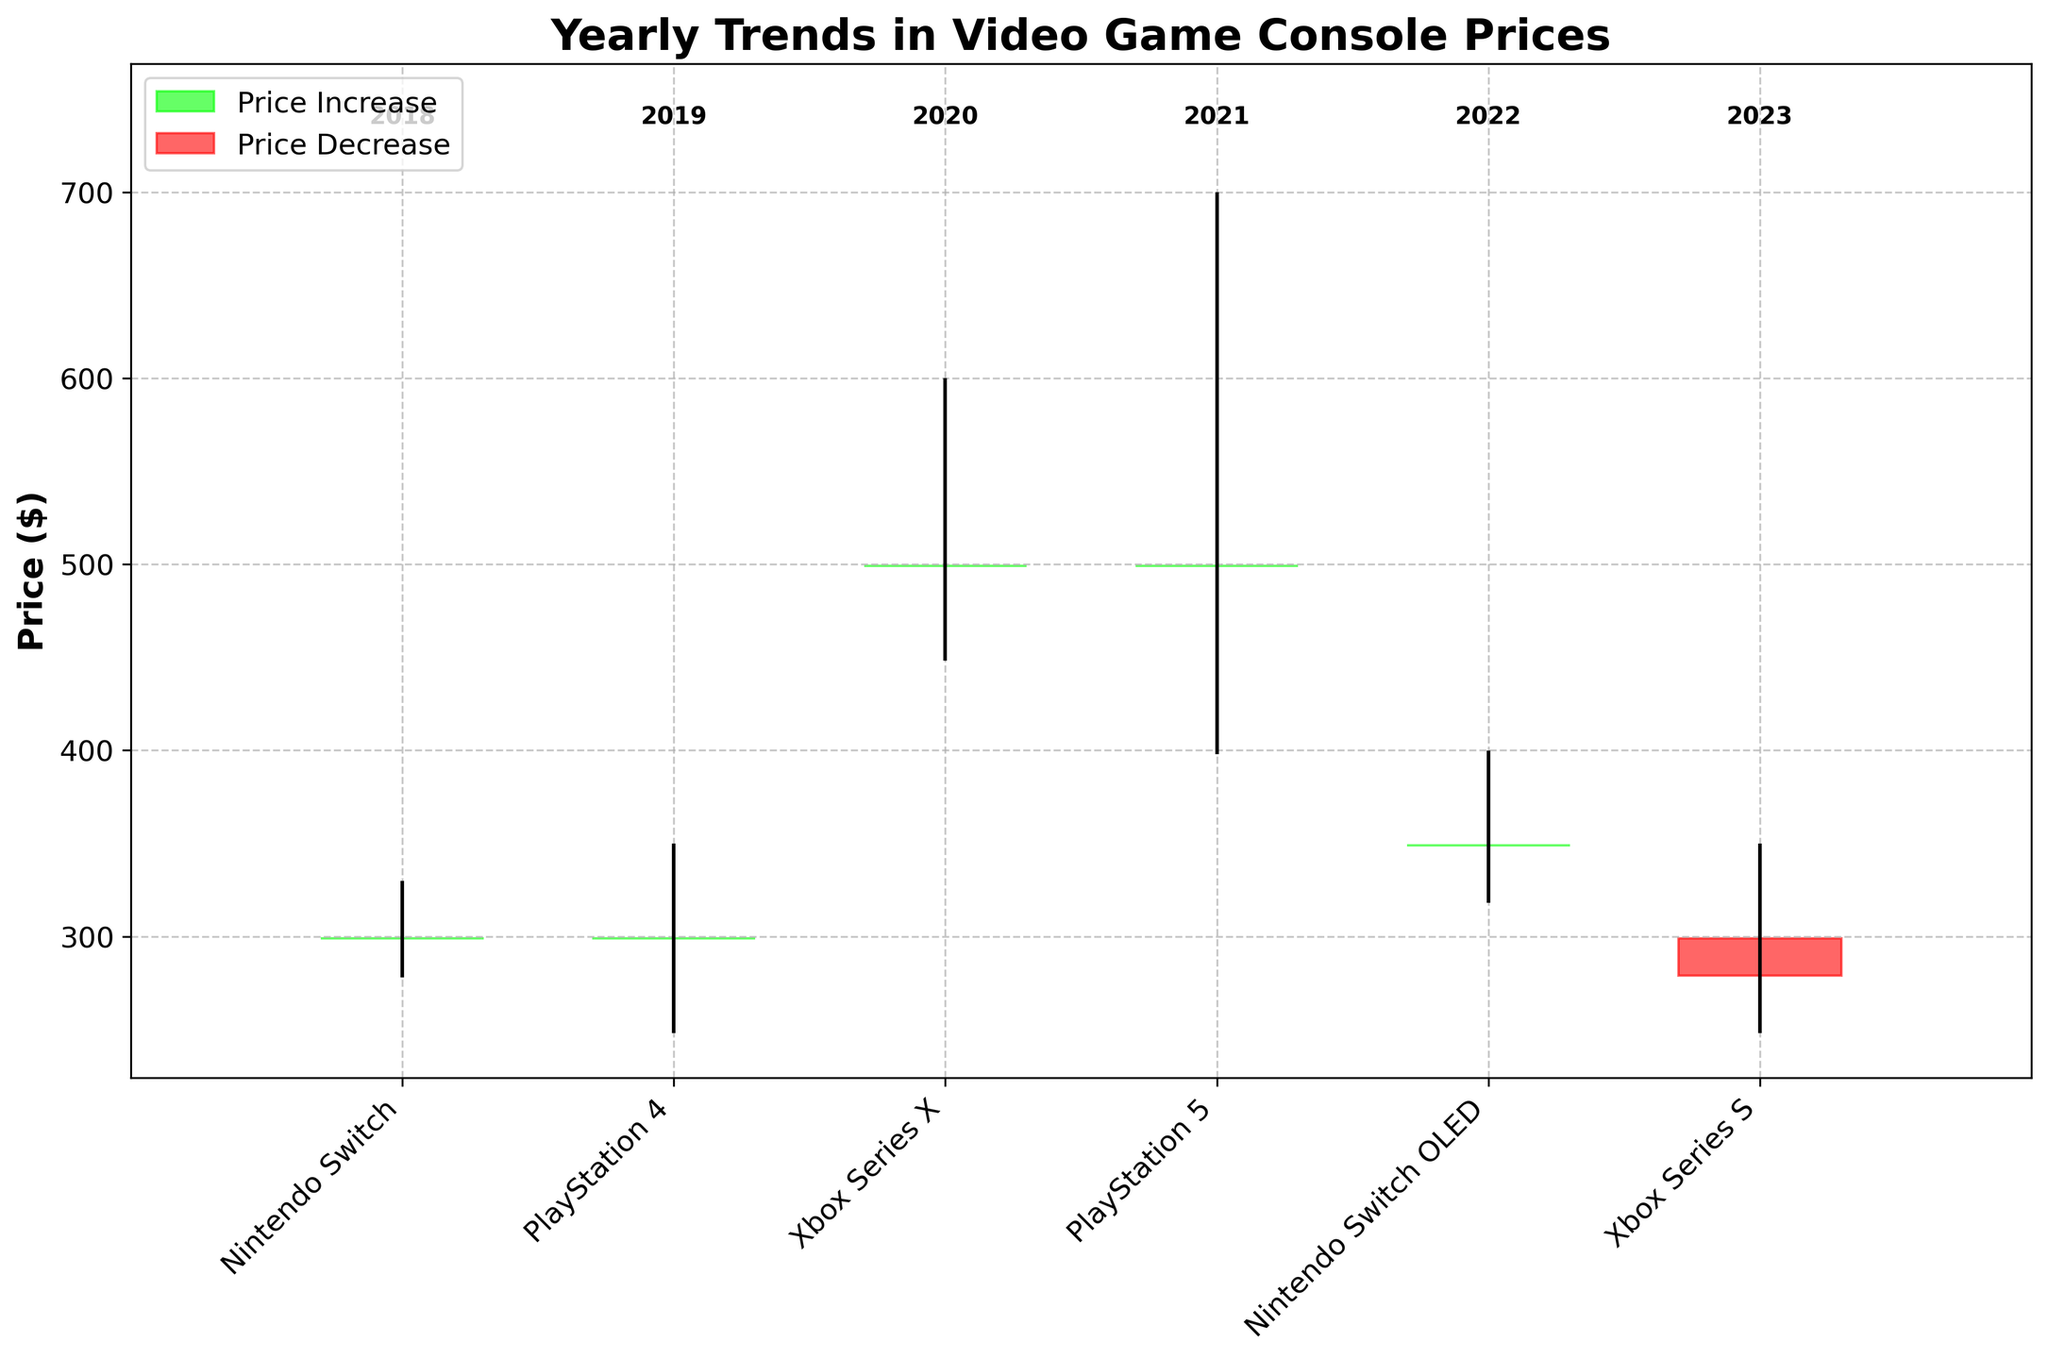What is the title of the plot? The title of the plot is usually located at the top and gives a brief description of the visualized data. Here, it is written as "Yearly Trends in Video Game Console Prices" in bold.
Answer: Yearly Trends in Video Game Console Prices Which consoles had their closing price equal to the opening price? Check the bars where the top and bottom of the rectangles are at the same level. This indicates that the closing price is equal to the opening price. For this figure, both the Nintendo Switch in 2018 and the PlayStation 4 in 2019 have such characteristics.
Answer: Nintendo Switch 2018 and PlayStation 4 2019 Was there any console whose closing price was lower than its opening price? Look for rectangles colored in red, indicating a price decrease from open to close. The only such console is the Xbox Series S in 2023.
Answer: Xbox Series S 2023 How many consoles increased in price by the end of their year? Count the number of green rectangles, which represent consoles where the closing price was higher than the opening price. There are four such consoles.
Answer: Four Which year had the highest price for any console, and what was that price? Look for the highest point on the vertical lines (the wicks) of the graph, which indicates the highest price reached for any console. The highest price on the chart is $699, achieved in 2021 by the PlayStation 5.
Answer: 2021, $699 What was the range of prices for the PlayStation 5 in 2021? The range is the difference between the highest and lowest prices for a given console. For the PlayStation 5 in 2021, the highest price is $699 and the lowest is $399.
Answer: $300 Which console had the smallest difference between its high and low prices? Calculate the difference between the highest and lowest prices for each console. The console with the smallest range is the Nintendo Switch OLED in 2022, which had a range of $80 ($399 - $319).
Answer: Nintendo Switch OLED Compare the opening prices of PlayStation 4 and PlayStation 5. Which one is higher and by how much? The opening price for PlayStation 4 in 2019 is $299 and for PlayStation 5 in 2021 is $499. Subtracting the two, PlayStation 5’s opening price is $200 higher.
Answer: PlayStation 5 by $200 What trend do you observe in the prices from 2018 to 2023? Observing the chart from left to right, note the general increase in both opening and closing prices over the years, with the highest peaks between 2020 and 2021. The prices then slightly decrease by 2023.
Answer: General increase with peaks in 2020 and 2021 Which year had the console with the lowest price, and what was that price? Find the shortest vertical line (wak) downward on the graph, indicating the lowest price reached. In 2019, the PlayStation 4 had the lowest price of $249.
Answer: 2019, $249 